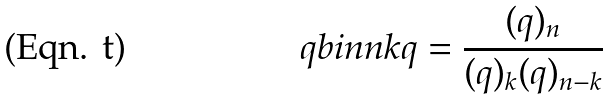Convert formula to latex. <formula><loc_0><loc_0><loc_500><loc_500>\ q b i n { n } { k } { q } = \frac { ( q ) _ { n } } { ( q ) _ { k } ( q ) _ { n - k } }</formula> 